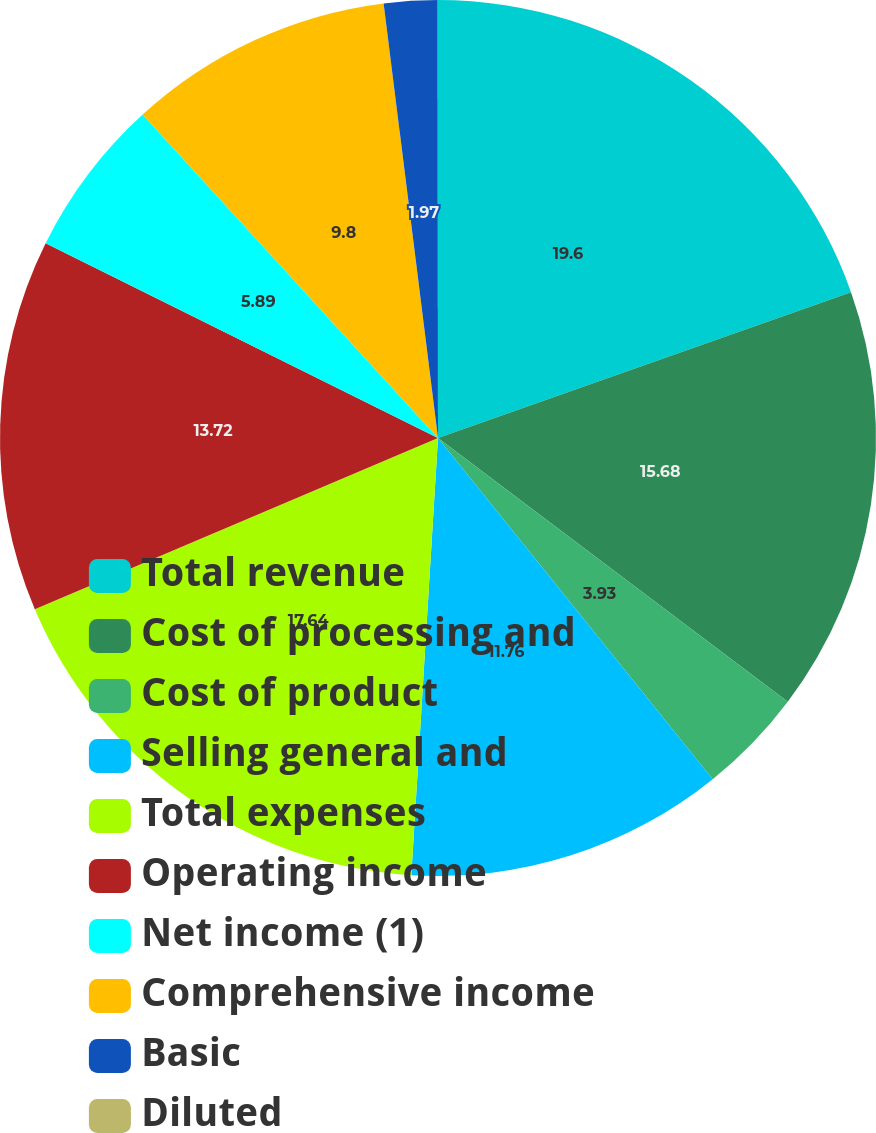Convert chart. <chart><loc_0><loc_0><loc_500><loc_500><pie_chart><fcel>Total revenue<fcel>Cost of processing and<fcel>Cost of product<fcel>Selling general and<fcel>Total expenses<fcel>Operating income<fcel>Net income (1)<fcel>Comprehensive income<fcel>Basic<fcel>Diluted<nl><fcel>19.6%<fcel>15.68%<fcel>3.93%<fcel>11.76%<fcel>17.64%<fcel>13.72%<fcel>5.89%<fcel>9.8%<fcel>1.97%<fcel>0.01%<nl></chart> 